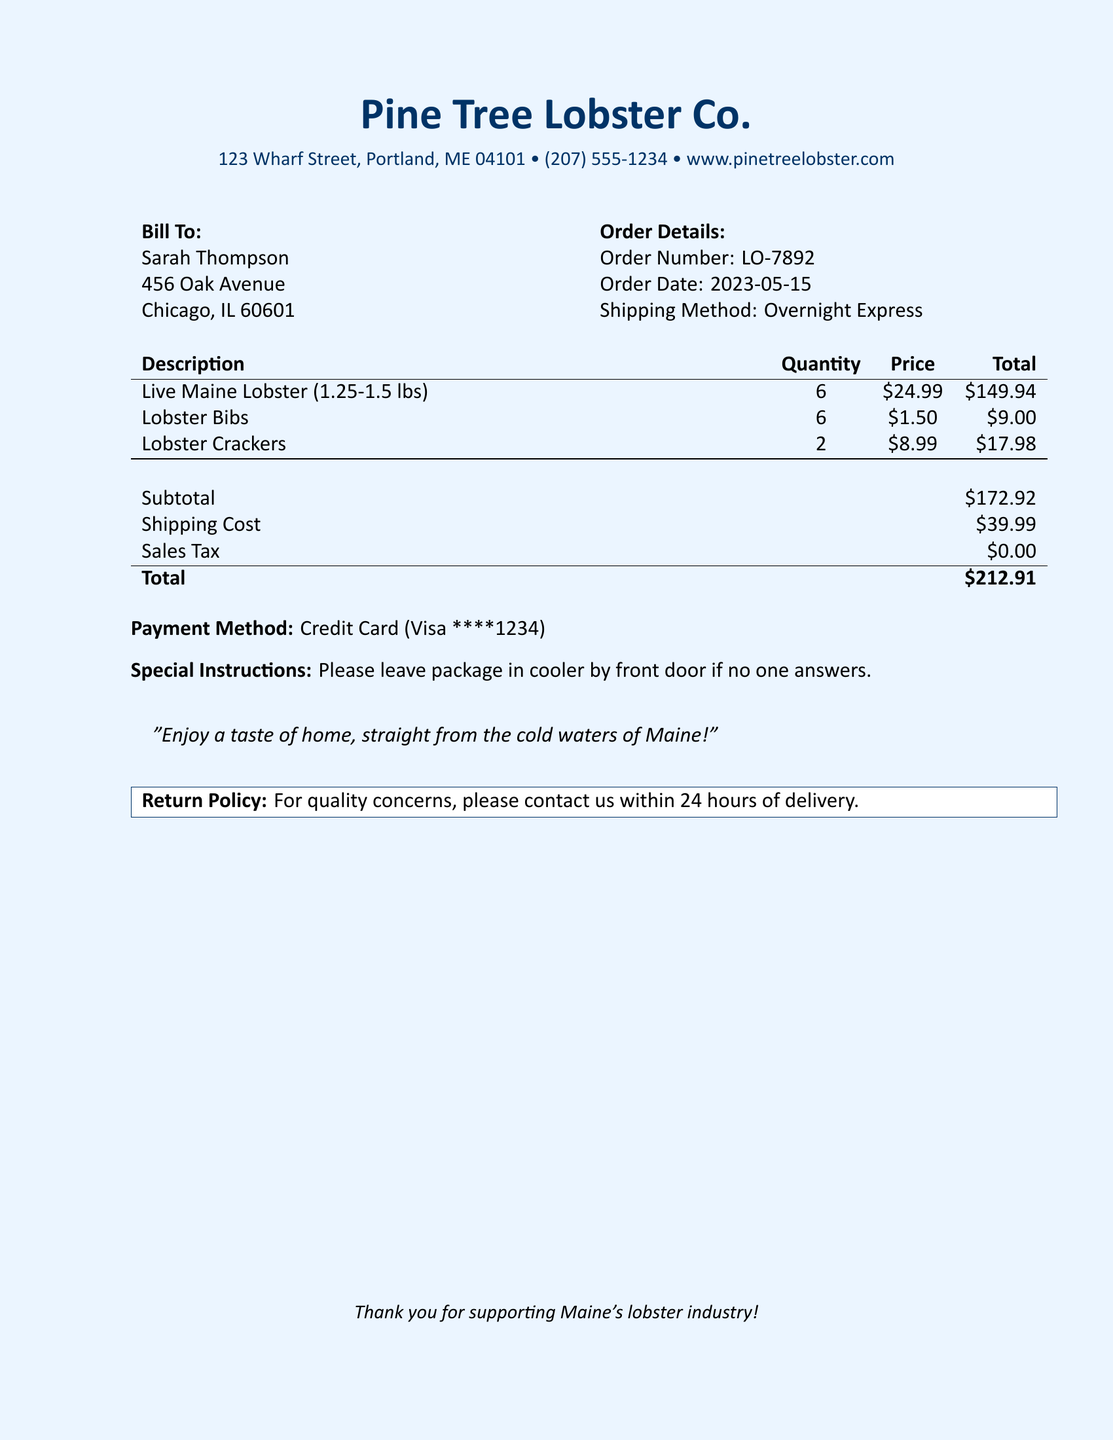What is the name of the company? The name of the company is located at the top of the document.
Answer: Pine Tree Lobster Co What is the order number? The order number is listed under Order Details in the document.
Answer: LO-7892 What is the shipping cost? The shipping cost is found in the financial summary section of the document.
Answer: $39.99 How many live lobsters were ordered? The quantity of live lobsters is noted in the description table.
Answer: 6 What is the total amount due? The total amount due is highlighted at the bottom of the financial summary.
Answer: $212.91 What payment method was used? The payment method is specified in the document under Payment Method.
Answer: Credit Card (Visa ****1234) What special instructions were provided? The special instructions are included towards the end of the document.
Answer: Please leave package in cooler by front door if no one answers What is the subtotal before shipping and tax? The subtotal is provided in the financial summary section.
Answer: $172.92 What is the return policy contact timeframe? The return policy contact information is mentioned in the return policy section.
Answer: 24 hours 